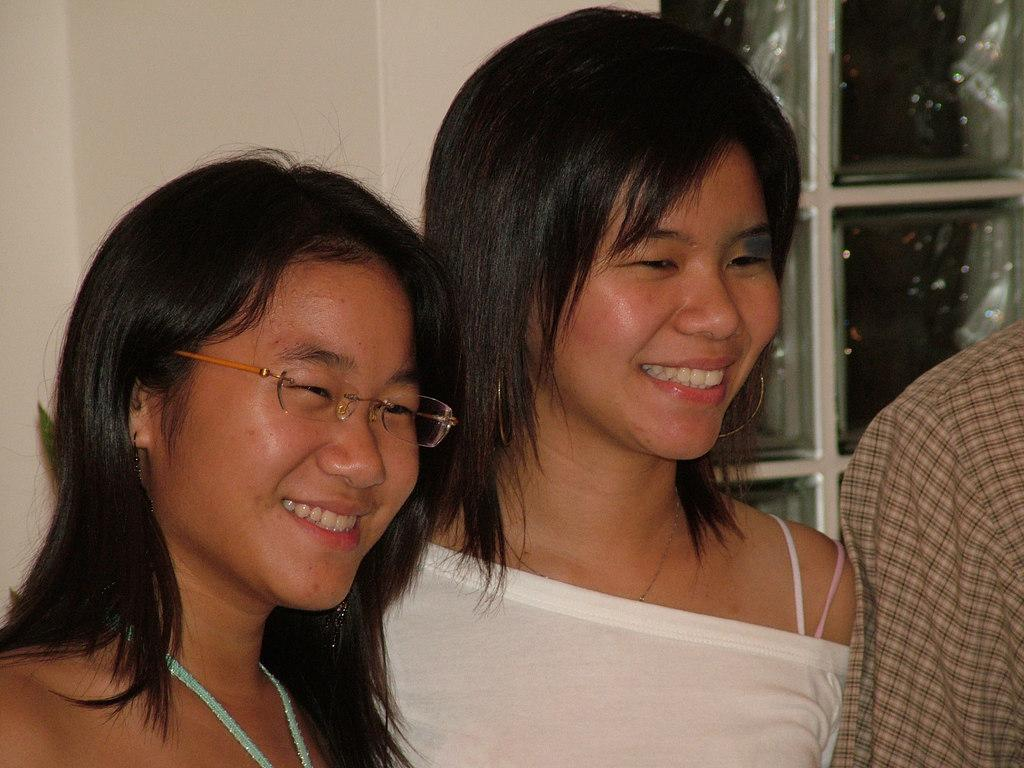How many people are present in the image? There are three people standing in the image. Can you describe the two people in the foreground? Two women are standing in the foreground, and they are smiling. What can be seen in the background of the image? There is a wall in the background, and it has glass windows. What type of horse is depicted in the locket around the neck of one of the women? There is no horse or locket present in the image. 